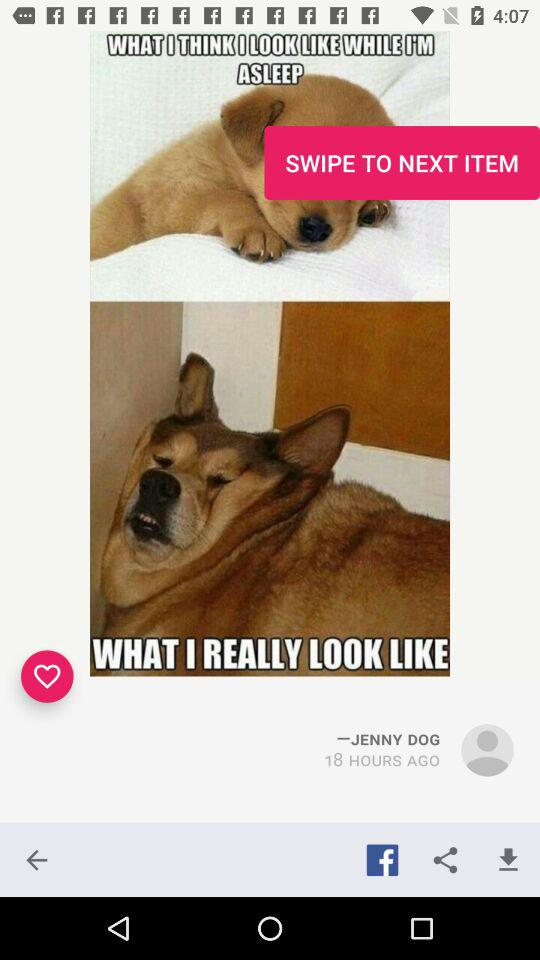Who uploaded the photo? The photo was uploaded by "JENNY DOG". 